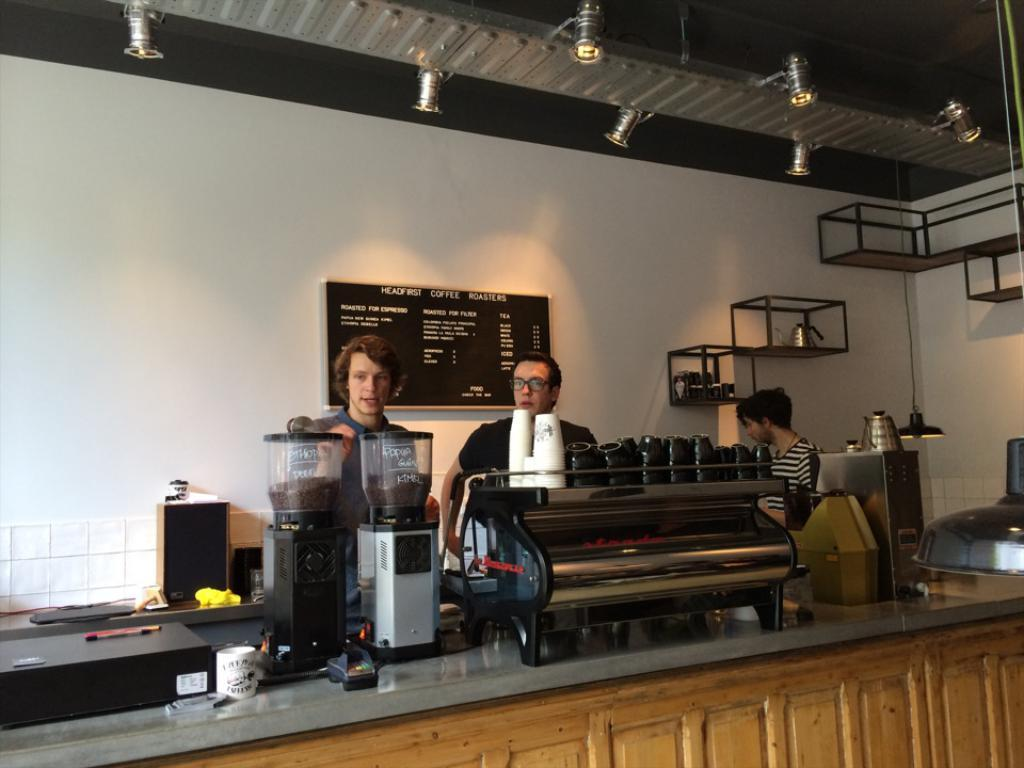Provide a one-sentence caption for the provided image. people behind the bar of a HEADFIRST Coffee Roasters as worded on the menu board. 